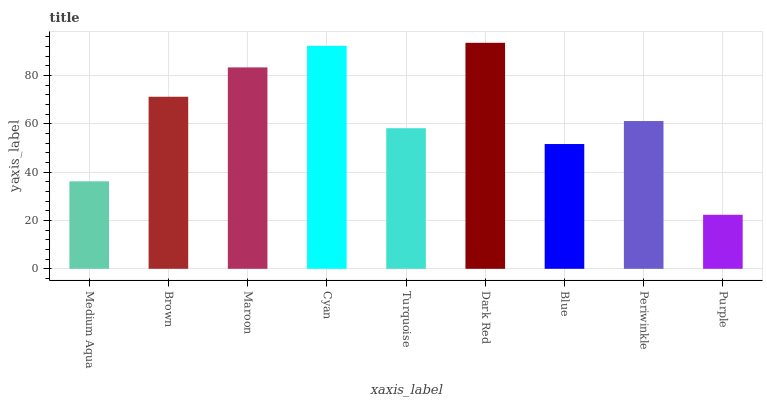Is Purple the minimum?
Answer yes or no. Yes. Is Dark Red the maximum?
Answer yes or no. Yes. Is Brown the minimum?
Answer yes or no. No. Is Brown the maximum?
Answer yes or no. No. Is Brown greater than Medium Aqua?
Answer yes or no. Yes. Is Medium Aqua less than Brown?
Answer yes or no. Yes. Is Medium Aqua greater than Brown?
Answer yes or no. No. Is Brown less than Medium Aqua?
Answer yes or no. No. Is Periwinkle the high median?
Answer yes or no. Yes. Is Periwinkle the low median?
Answer yes or no. Yes. Is Medium Aqua the high median?
Answer yes or no. No. Is Turquoise the low median?
Answer yes or no. No. 